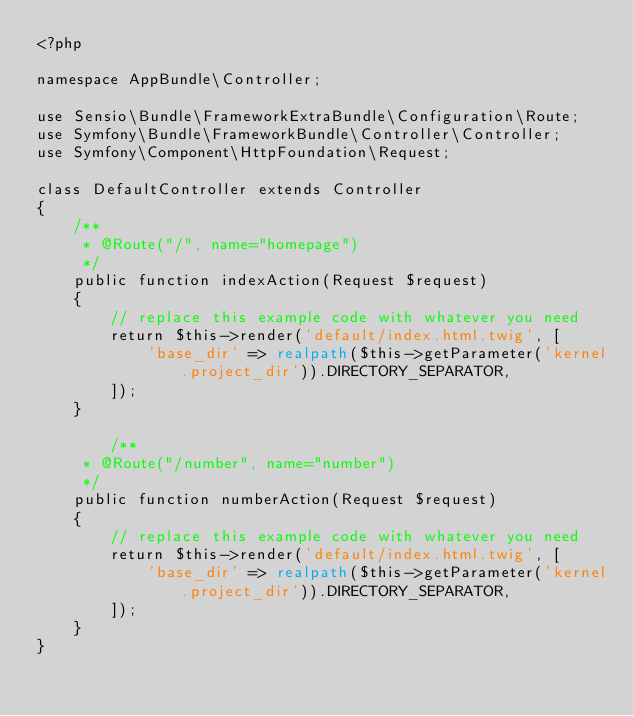<code> <loc_0><loc_0><loc_500><loc_500><_PHP_><?php

namespace AppBundle\Controller;

use Sensio\Bundle\FrameworkExtraBundle\Configuration\Route;
use Symfony\Bundle\FrameworkBundle\Controller\Controller;
use Symfony\Component\HttpFoundation\Request;

class DefaultController extends Controller
{
    /**
     * @Route("/", name="homepage")
     */
    public function indexAction(Request $request)
    {
        // replace this example code with whatever you need
        return $this->render('default/index.html.twig', [
            'base_dir' => realpath($this->getParameter('kernel.project_dir')).DIRECTORY_SEPARATOR,
        ]);
    }
    
        /**
     * @Route("/number", name="number")
     */
    public function numberAction(Request $request)
    {
        // replace this example code with whatever you need
        return $this->render('default/index.html.twig', [
            'base_dir' => realpath($this->getParameter('kernel.project_dir')).DIRECTORY_SEPARATOR,
        ]);
    }
}
</code> 